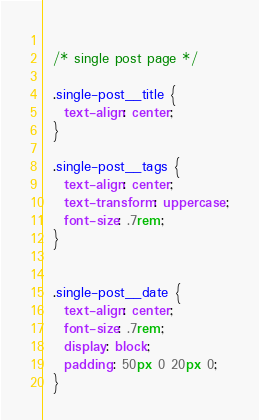Convert code to text. <code><loc_0><loc_0><loc_500><loc_500><_CSS_>  
  /* single post page */
  
  .single-post__title {
    text-align: center;
  }
  
  .single-post__tags {
    text-align: center;
    text-transform: uppercase;
    font-size: .7rem;
  }
  
  
  .single-post__date {
    text-align: center;
    font-size: .7rem;
    display: block;
    padding: 50px 0 20px 0;
  }</code> 